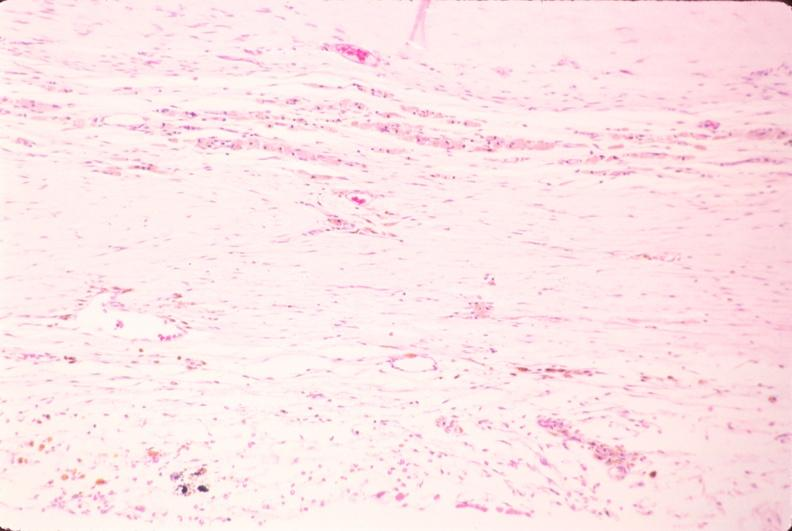what is present?
Answer the question using a single word or phrase. Nervous 